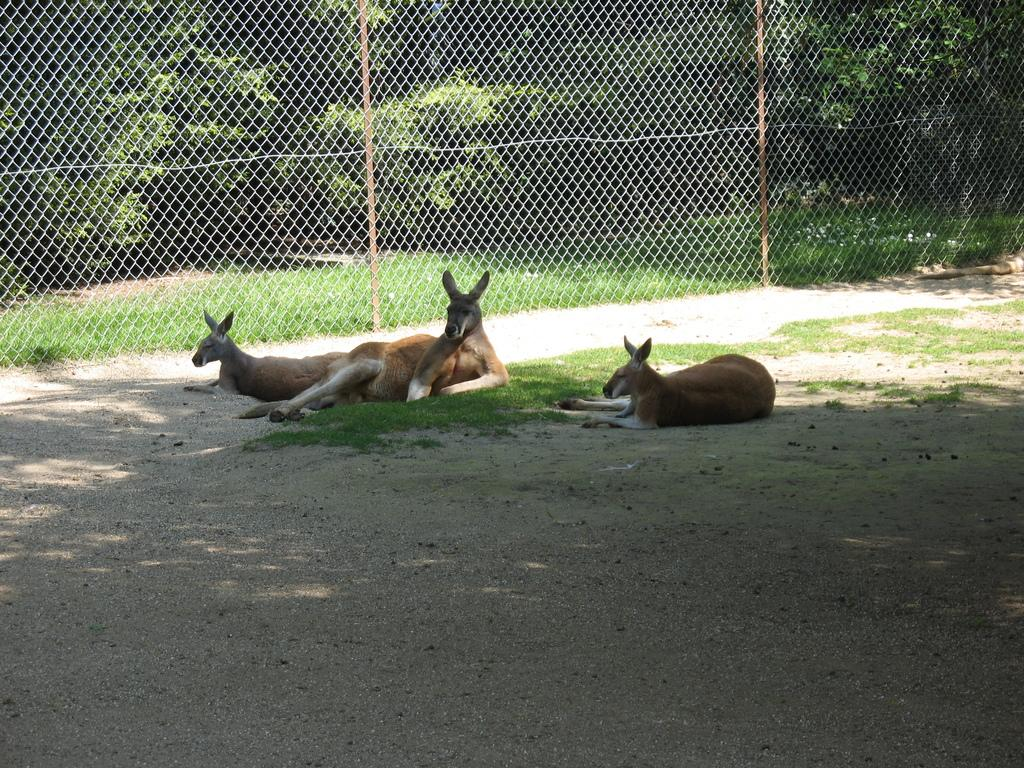What type of animals can be seen in the image? There are animals on the sand in the image. What natural elements are present in the image? There are trees and grass in the image. What type of barrier can be seen in the image? There is net fencing in the image. What type of jeans are the bears wearing in the image? There are no bears or jeans present in the image. What type of mountain can be seen in the background of the image? There is no mountain visible in the image. 